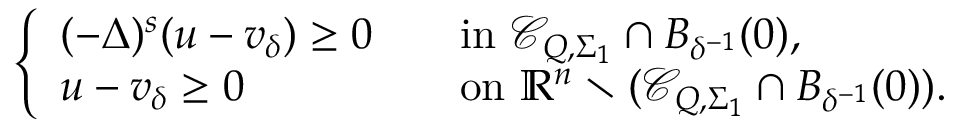<formula> <loc_0><loc_0><loc_500><loc_500>\left \{ \begin{array} { l l } { ( - \Delta ) ^ { s } ( u - v _ { \delta } ) \geq 0 \quad } & { i n \, \mathcal { C } _ { Q , \Sigma _ { 1 } } \cap B _ { \delta ^ { - 1 } } ( 0 ) , } \\ { u - v _ { \delta } \geq 0 } & { o n \, \mathbb { R } ^ { n } \ ( \mathcal { C } _ { Q , \Sigma _ { 1 } } \cap B _ { \delta ^ { - 1 } } ( 0 ) ) . } \end{array}</formula> 